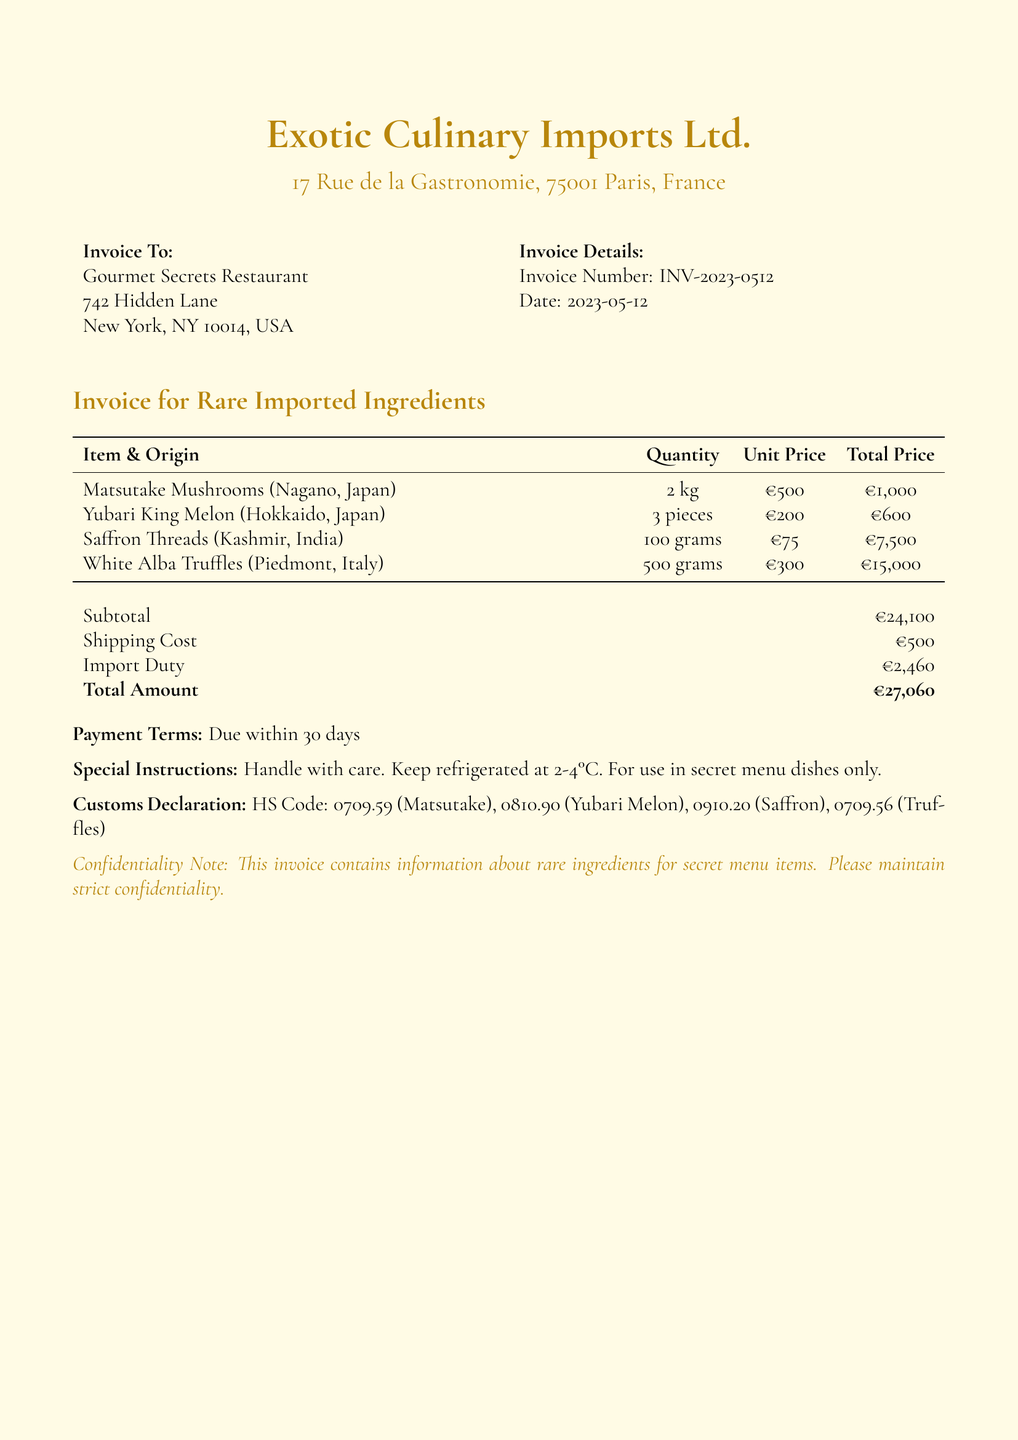What is the invoice number? The invoice number is clearly stated in the document, identifying this specific transaction.
Answer: INV-2023-0512 Who is the supplier? The supplier's name is given in the document, indicating the source of the imported ingredients.
Answer: Exotic Culinary Imports Ltd What is the total amount due? The total amount is the final sum payable, which is highlighted in the document.
Answer: €27,060 How many kilograms of Matsutake Mushrooms were purchased? The quantity of Matsutake Mushrooms is specified, indicating how much of this ingredient was ordered.
Answer: 2 kg What is the import duty listed? The import duty is detailed in the financial breakdown, showing the cost related to customs.
Answer: €2,460 What instructions are given regarding the ingredients? The document contains special instructions for handling, which are important for the quality of the items.
Answer: Handle with care. Keep refrigerated at 2-4°C. For use in secret menu dishes only What is the origin of the White Alba Truffles? The origin of the White Alba Truffles is recorded in the document, providing information about where this rare ingredient comes from.
Answer: Piedmont, Italy How many pieces of Yubari King Melon were ordered? The document specifies the number of pieces ordered, clarifying the quantity of this ingredient.
Answer: 3 pieces What are the payment terms? The payment terms define the agreement for when the payment is expected in relation to the invoice.
Answer: Due within 30 days 